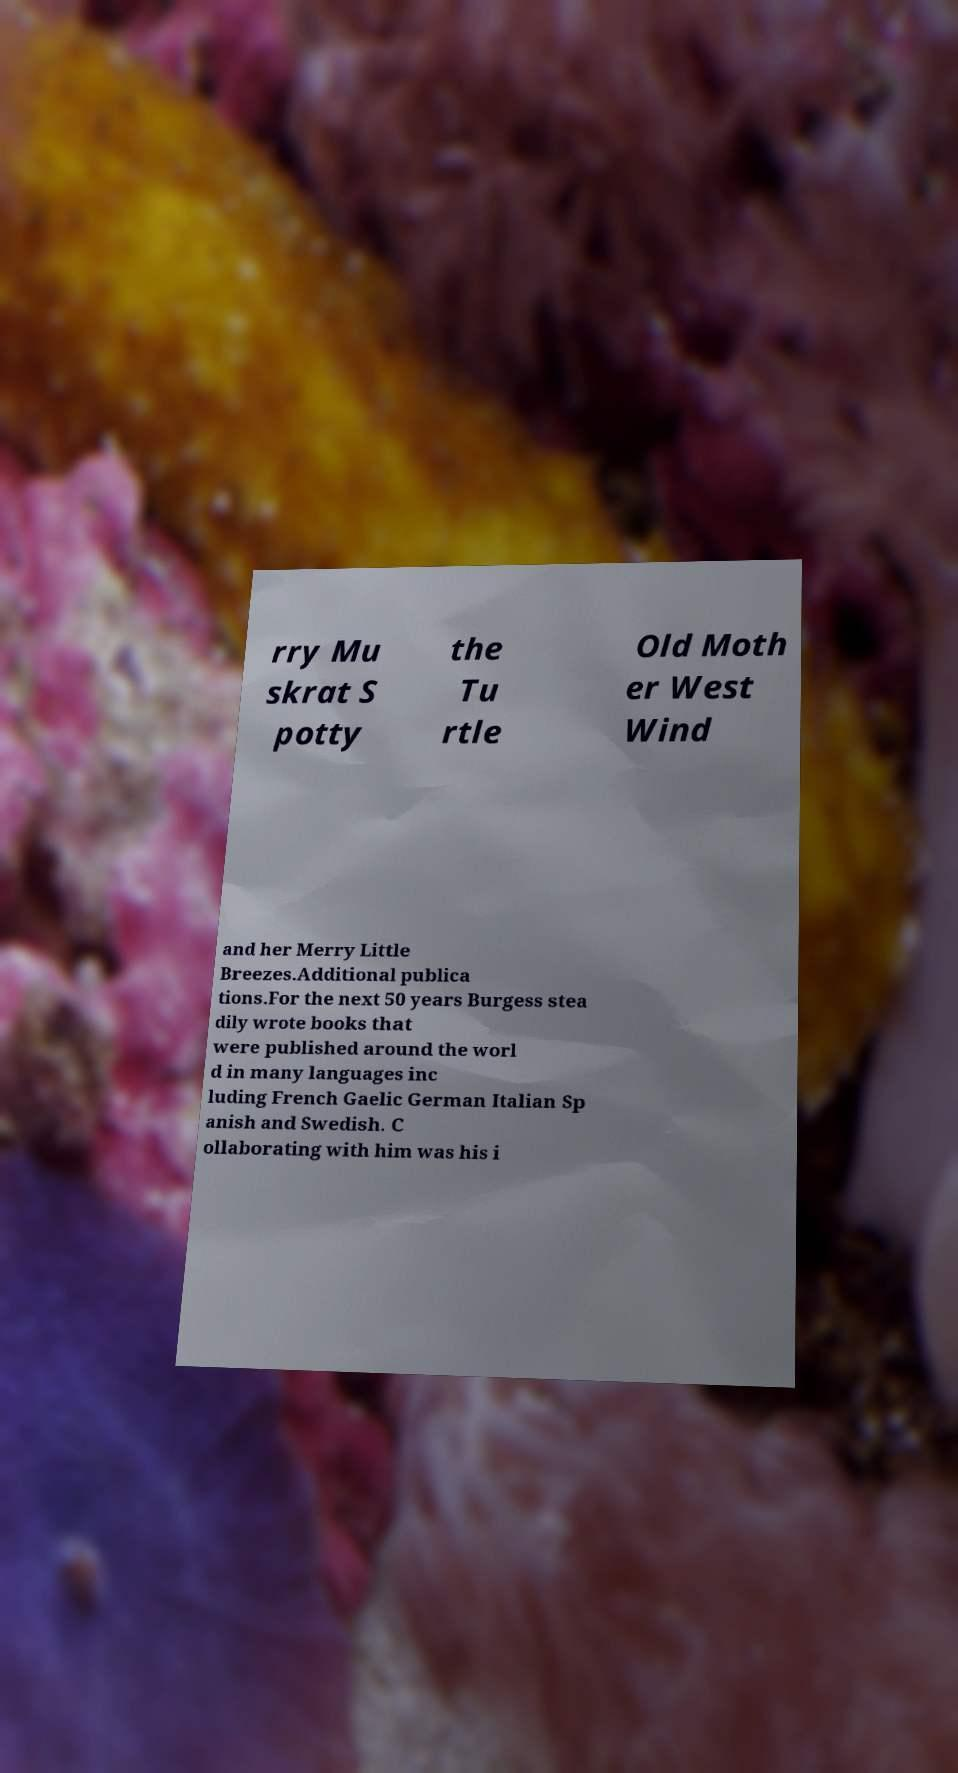For documentation purposes, I need the text within this image transcribed. Could you provide that? rry Mu skrat S potty the Tu rtle Old Moth er West Wind and her Merry Little Breezes.Additional publica tions.For the next 50 years Burgess stea dily wrote books that were published around the worl d in many languages inc luding French Gaelic German Italian Sp anish and Swedish. C ollaborating with him was his i 